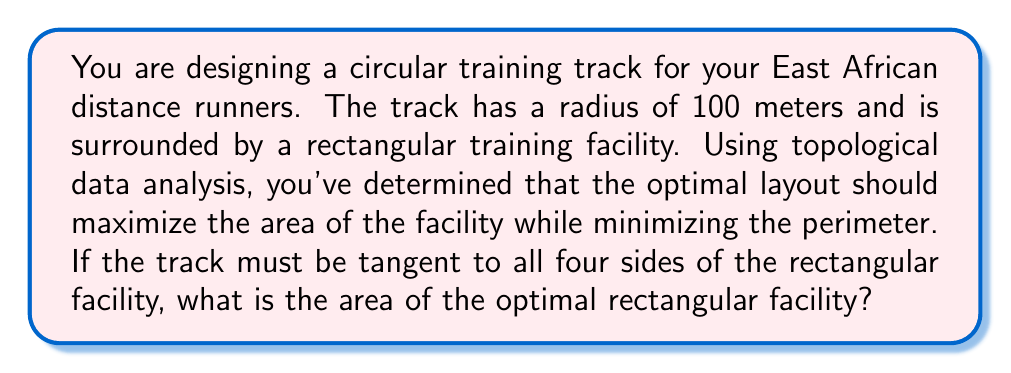Help me with this question. Let's approach this step-by-step:

1) Let the width of the rectangle be $2x$ and the length be $2y$. The circle (track) must be tangent to all four sides of the rectangle.

2) Given this setup, we can deduce that the center of the circle coincides with the center of the rectangle.

3) The radius of the circle is 100 meters. This means:

   $x^2 + y^2 = 100^2 = 10000$

4) The area of the rectangle is:

   $A = 4xy$

5) We want to maximize this area subject to the constraint $x^2 + y^2 = 10000$.

6) We can use the method of Lagrange multipliers. Let:

   $L(x, y, \lambda) = 4xy - \lambda(x^2 + y^2 - 10000)$

7) Taking partial derivatives and setting them to zero:

   $\frac{\partial L}{\partial x} = 4y - 2\lambda x = 0$
   $\frac{\partial L}{\partial y} = 4x - 2\lambda y = 0$
   $\frac{\partial L}{\partial \lambda} = x^2 + y^2 - 10000 = 0$

8) From the first two equations:

   $2y = \lambda x$ and $2x = \lambda y$

9) Dividing these:

   $\frac{y}{x} = \frac{x}{y}$

   This is only true if $x = y$.

10) Substituting this back into the constraint equation:

    $2x^2 = 10000$
    $x^2 = 5000$
    $x = y = \sqrt{5000} = 50\sqrt{2}$

11) Therefore, the dimensions of the optimal rectangle are $100\sqrt{2}$ by $100\sqrt{2}$ meters.

12) The area of this rectangle is:

    $A = (100\sqrt{2})(100\sqrt{2}) = 20000$ square meters
Answer: The area of the optimal rectangular facility is 20000 square meters. 